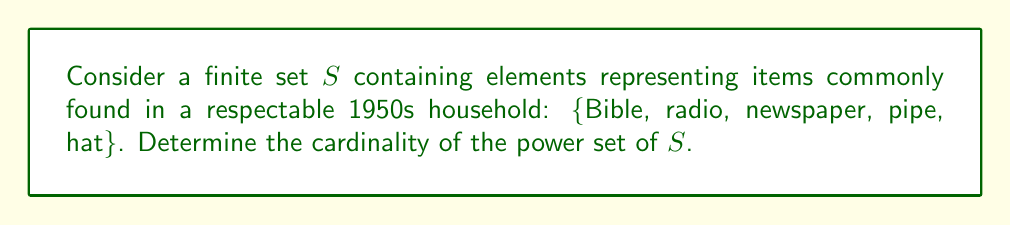What is the answer to this math problem? To solve this problem, let's follow these steps:

1) First, recall that the power set of a set $S$ is the set of all subsets of $S$, including the empty set and $S$ itself.

2) The cardinality of a set is the number of elements in that set.

3) For a finite set with $n$ elements, the cardinality of its power set is given by the formula $2^n$.

4) In our case, the set $S$ contains 5 elements: 
   $S = $ {Bible, radio, newspaper, pipe, hat}

5) Therefore, $n = 5$

6) Applying the formula:
   Cardinality of power set of $S = 2^5 = 32$

To understand why this is true, consider that for each element in the original set, we have two choices: either include it in a subset or not. This gives us $2 \times 2 \times 2 \times 2 \times 2 = 2^5 = 32$ possible combinations.

These 32 subsets would include:
- The empty set {}
- 5 subsets with one element each
- 10 subsets with two elements each
- 10 subsets with three elements each
- 5 subsets with four elements each
- The full set {Bible, radio, newspaper, pipe, hat}

This enumeration confirms our calculation of $2^5 = 32$ subsets in total.
Answer: The cardinality of the power set of $S$ is $2^5 = 32$. 